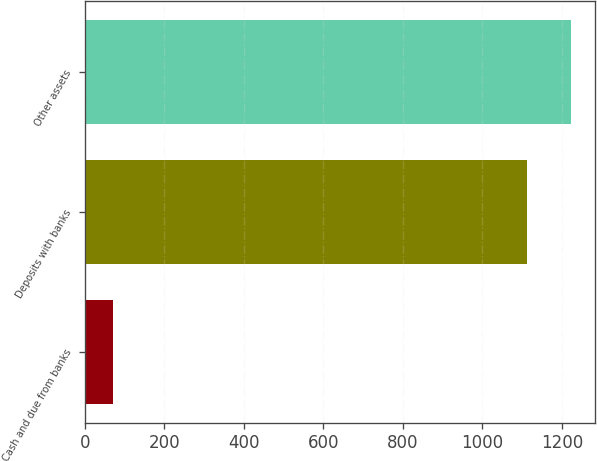Convert chart to OTSL. <chart><loc_0><loc_0><loc_500><loc_500><bar_chart><fcel>Cash and due from banks<fcel>Deposits with banks<fcel>Other assets<nl><fcel>71<fcel>1112<fcel>1223.2<nl></chart> 